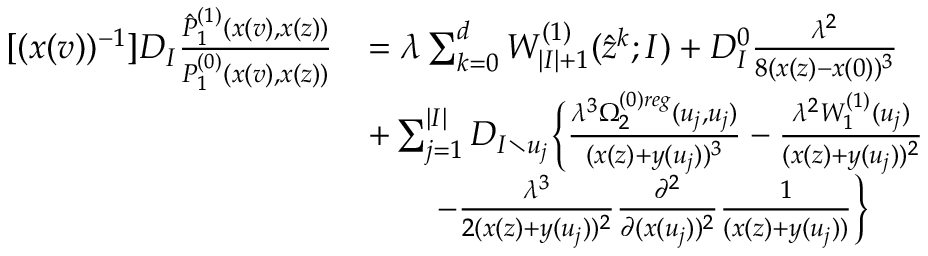<formula> <loc_0><loc_0><loc_500><loc_500>\begin{array} { r l } { [ ( x ( v ) ) ^ { - 1 } ] D _ { I } \frac { \hat { P } _ { 1 } ^ { ( 1 ) } ( x ( v ) , x ( z ) ) } { P _ { 1 } ^ { ( 0 ) } ( x ( v ) , x ( z ) ) } } & { = \lambda \sum _ { k = 0 } ^ { d } W _ { | I | + 1 } ^ { ( 1 ) } ( \hat { z } ^ { k } ; I ) + D _ { I } ^ { 0 } \frac { \lambda ^ { 2 } } { 8 ( x ( z ) - x ( 0 ) ) ^ { 3 } } } \\ & { + \sum _ { j = 1 } ^ { | I | } D _ { I \ u _ { j } } \left \{ \frac { \lambda ^ { 3 } \Omega _ { 2 } ^ { ( 0 ) r e g } ( u _ { j } , u _ { j } ) } { ( x ( z ) + y ( u _ { j } ) ) ^ { 3 } } - \frac { \lambda ^ { 2 } W _ { 1 } ^ { ( 1 ) } ( u _ { j } ) } { ( x ( z ) + y ( u _ { j } ) ) ^ { 2 } } } \\ & { \quad - \frac { \lambda ^ { 3 } } { 2 ( x ( z ) + y ( u _ { j } ) ) ^ { 2 } } \frac { \partial ^ { 2 } } { \partial ( x ( u _ { j } ) ) ^ { 2 } } \frac { 1 } { ( x ( z ) + y ( u _ { j } ) ) } \right \} } \end{array}</formula> 